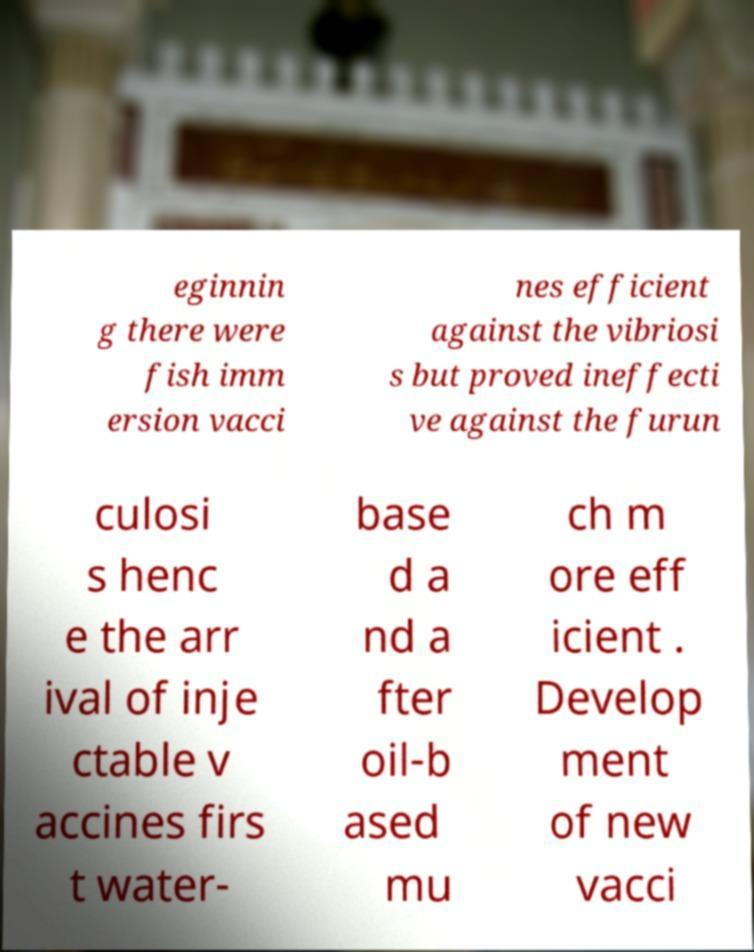For documentation purposes, I need the text within this image transcribed. Could you provide that? eginnin g there were fish imm ersion vacci nes efficient against the vibriosi s but proved ineffecti ve against the furun culosi s henc e the arr ival of inje ctable v accines firs t water- base d a nd a fter oil-b ased mu ch m ore eff icient . Develop ment of new vacci 